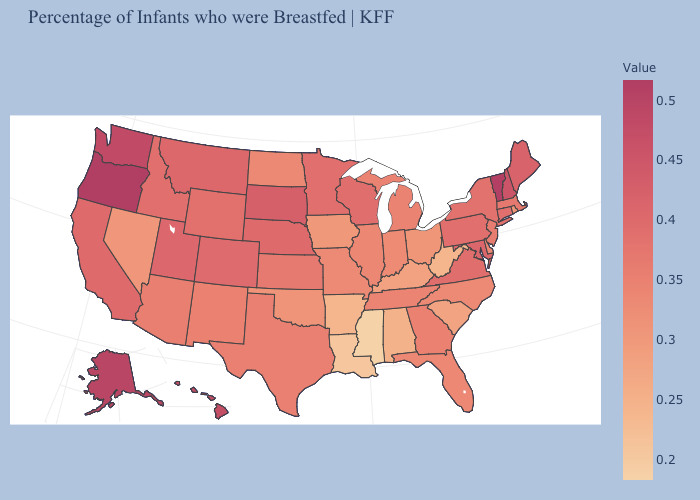Does the map have missing data?
Be succinct. No. Among the states that border Wyoming , which have the lowest value?
Short answer required. Idaho. Is the legend a continuous bar?
Concise answer only. Yes. Which states have the lowest value in the South?
Write a very short answer. Mississippi. Does Nevada have a higher value than Wisconsin?
Short answer required. No. Does the map have missing data?
Concise answer only. No. Which states have the lowest value in the West?
Quick response, please. Nevada. Does Arizona have the highest value in the West?
Short answer required. No. 